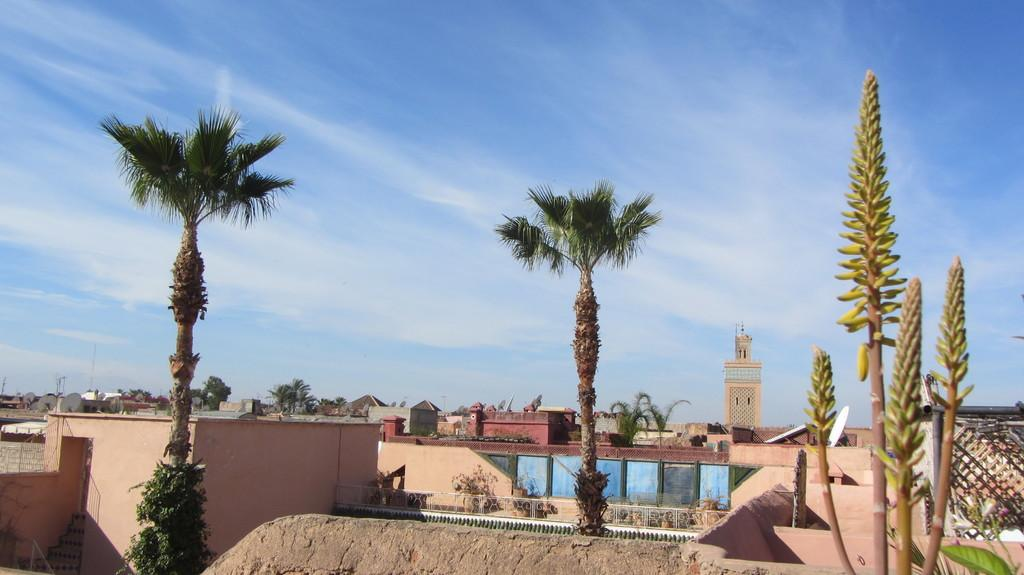What type of structures can be seen in the image? There are houses in the image. What type of vegetation is present in the image? There are trees and plants in the image. What is the boundary or barrier in the image? There is a wall in the image. What is visible in the background of the image? The sky is visible in the image. What type of copper legs can be seen supporting the houses in the image? There is no mention of copper legs or any legs supporting the houses in the image. The houses are likely built on foundations or other structural supports, but these are not visible in the image. 